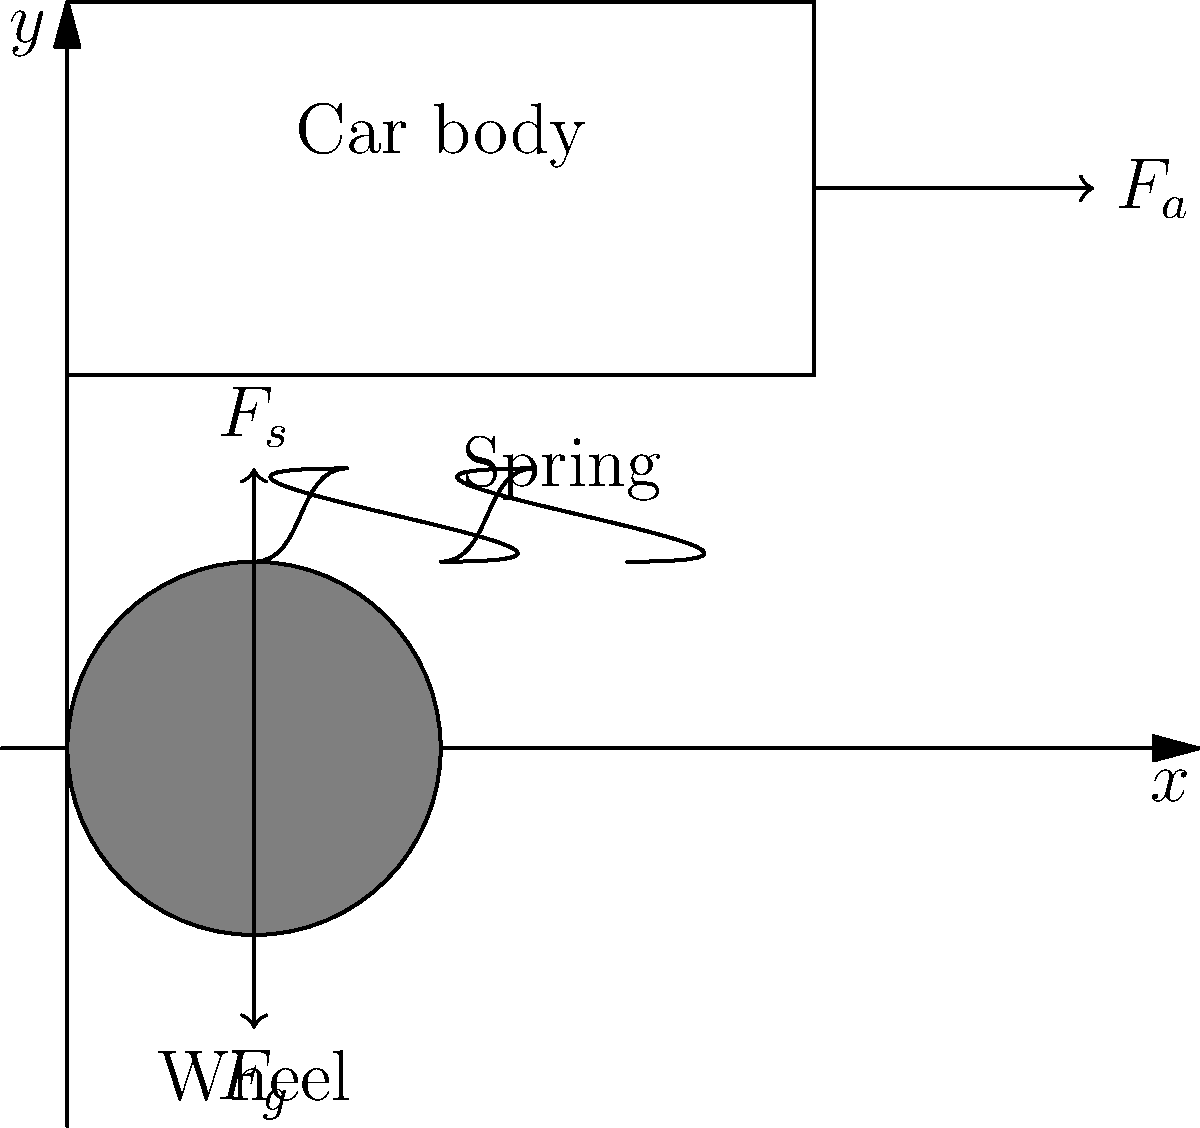As a racing team owner, you're analyzing the suspension dynamics of your car during a high-speed turn. The diagram shows a simplified model of the car's suspension system. If the centripetal force ($F_a$) acting on the car is 5000 N, the weight of the car ($F_g$) is 15000 N, and the suspension spring constant is 50000 N/m, what is the compression of the spring ($\Delta x$) in meters? Let's approach this step-by-step:

1) In equilibrium, the sum of forces in the vertical direction must be zero:
   $$F_s = F_g$$
   where $F_s$ is the force exerted by the spring.

2) During the turn, the centripetal force $F_a$ causes additional compression of the spring. The new equilibrium equation is:
   $$F_s = F_g + F_a$$

3) We know that the force exerted by a spring is given by Hooke's Law:
   $$F_s = k\Delta x$$
   where $k$ is the spring constant and $\Delta x$ is the compression of the spring.

4) Substituting this into our equilibrium equation:
   $$k\Delta x = F_g + F_a$$

5) Rearranging to solve for $\Delta x$:
   $$\Delta x = \frac{F_g + F_a}{k}$$

6) Now we can substitute our known values:
   $$\Delta x = \frac{15000 \text{ N} + 5000 \text{ N}}{50000 \text{ N/m}}$$

7) Simplifying:
   $$\Delta x = \frac{20000 \text{ N}}{50000 \text{ N/m}} = 0.4 \text{ m}$$

Therefore, the compression of the spring is 0.4 meters.
Answer: 0.4 m 